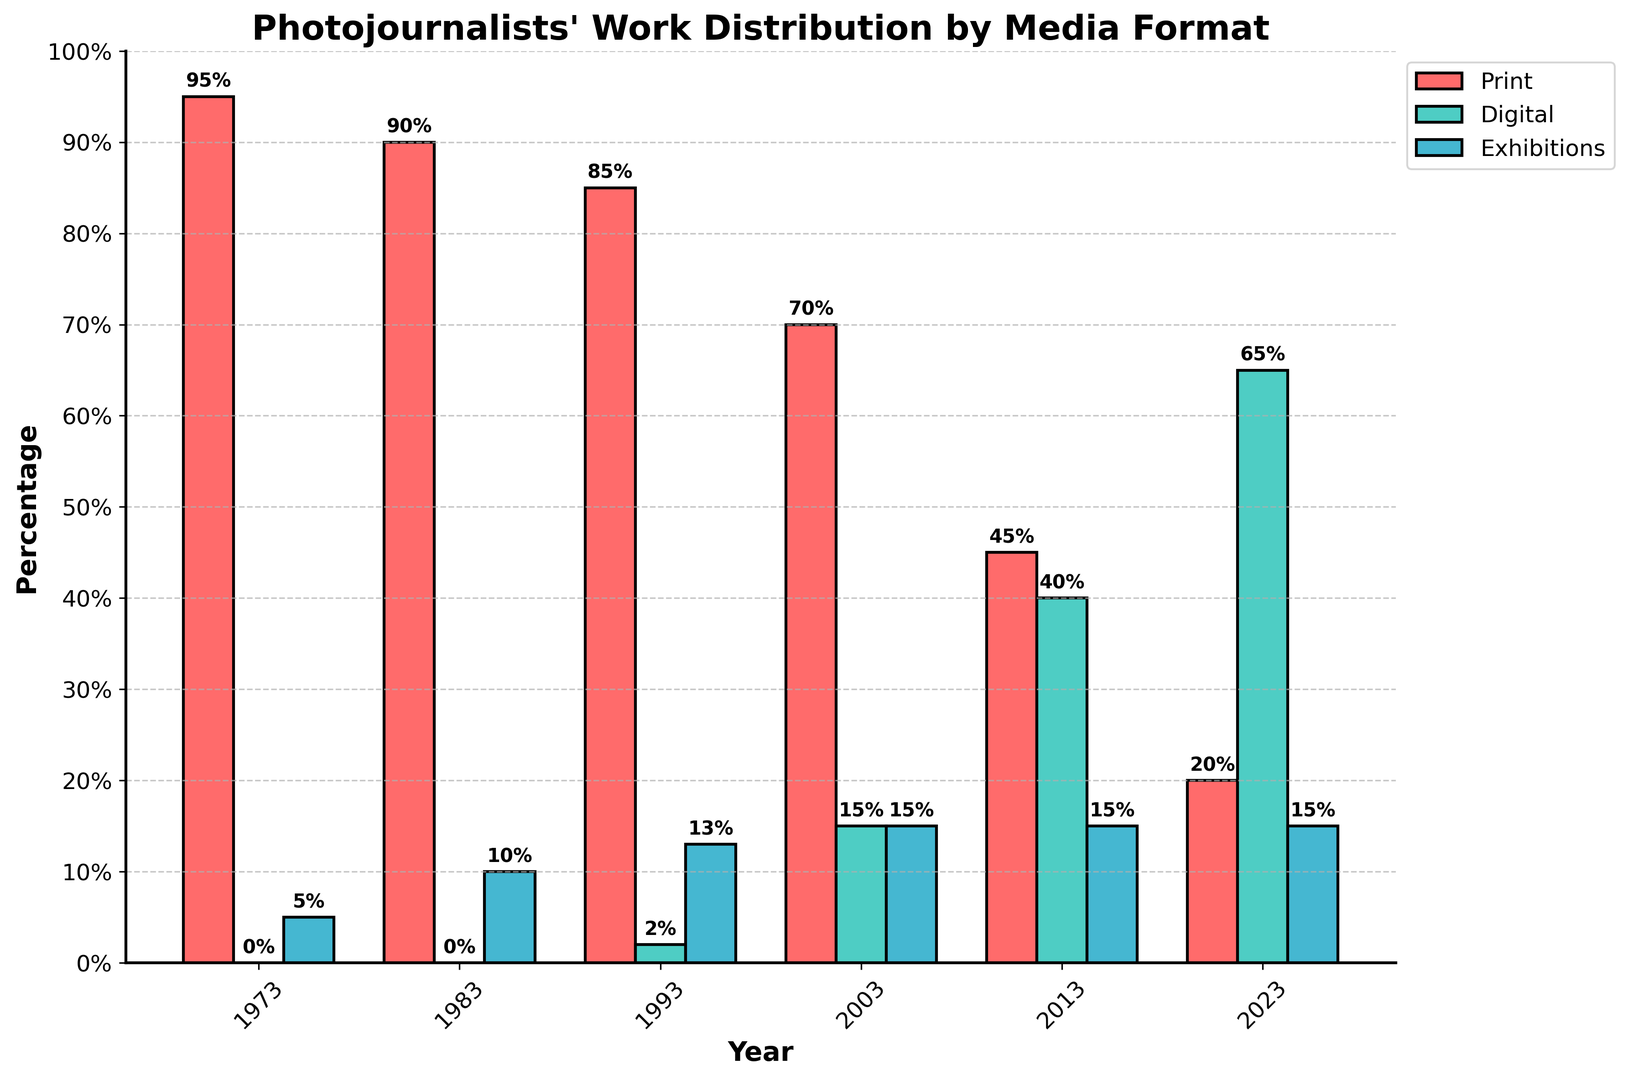Which year had the highest percentage of photojournalists' work published in print? Look at the 'Print' bars and find the highest one. It's the bar with the tallest height which corresponds to 1973.
Answer: 1973 In which year did photojournalists' work in digital media first appear in the data? Look at the 'Digital' bars and find the earliest year where the bar’s height for 'Digital' is greater than 0. This is seen in 1993.
Answer: 1993 What is the total percentage of work published in print and digital in 2013? Add the 'Print' and 'Digital' percentages for 2013. According to the data, Print is 45% and Digital is 40%, so 45% + 40%.
Answer: 85% How does the percentage of work published in exhibitions change from 1973 to 2023? Note the percentages for 'Exhibitions' in 1973 and 2023 and calculate the difference. In 1973, it’s 5%, and in 2023, it's 15%, showing an increase of 10%.
Answer: Increased by 10% Which media format has the most consistent percentage over the years? Compare the 'Print', 'Digital', and 'Exhibitions' bars across all years to see which remains relatively stable. 'Exhibitions' stays close to 15% after significant fluctuations early on.
Answer: Exhibitions What is the difference in the percentage of print media between 1983 and 2023? Subtract the 'Print' percentage in 2023 from that in 1983. In 1983, it is 90%, and in 2023, it is 20%, resulting in 90% - 20%.
Answer: 70% Calculate the average percentage of digital media usage over the years shown. Add the 'Digital' percentages for each year (0, 0, 2, 15, 40, 65) and divide by the number of years (6). Average = (0 + 0 + 2 + 15 + 40 + 65) / 6.
Answer: 20.33% Which year saw the largest increase in digital media usage compared to the previous decade? Compare the 'Digital' percentages year-to-year and identify the biggest increase. From 2013 to 2023, it jumps from 40% to 65%, an increase of 25%.
Answer: 2023 What trends can be observed about the use of print media over the last 50 years? Analyze the 'Print' bar heights over time. The trend shows a steady decline from 95% in 1973 to 20% in 2023.
Answer: Steady decline 